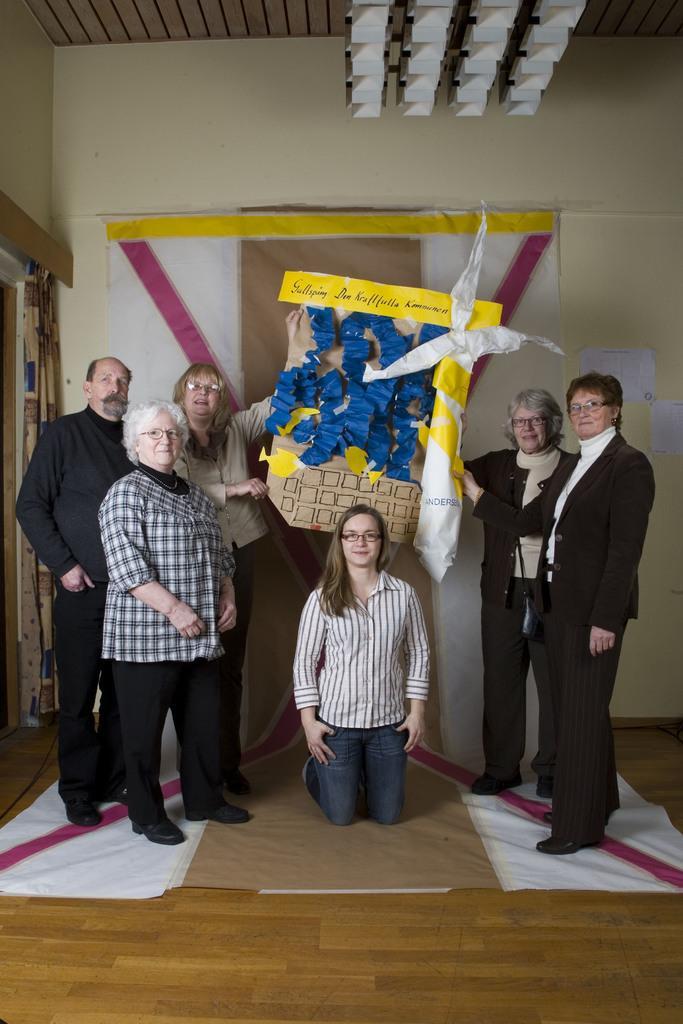Could you give a brief overview of what you see in this image? This picture is taken inside the room. In this image, in the middle, we can see a woman sitting on the mat. On the right side and left side, we can see a group of people holding a board. On the left side, we can see a curtain. In the background, we can see a cloth. At the top, we can see a roof with few lights. At the bottom, we can see a mat and a floor. 